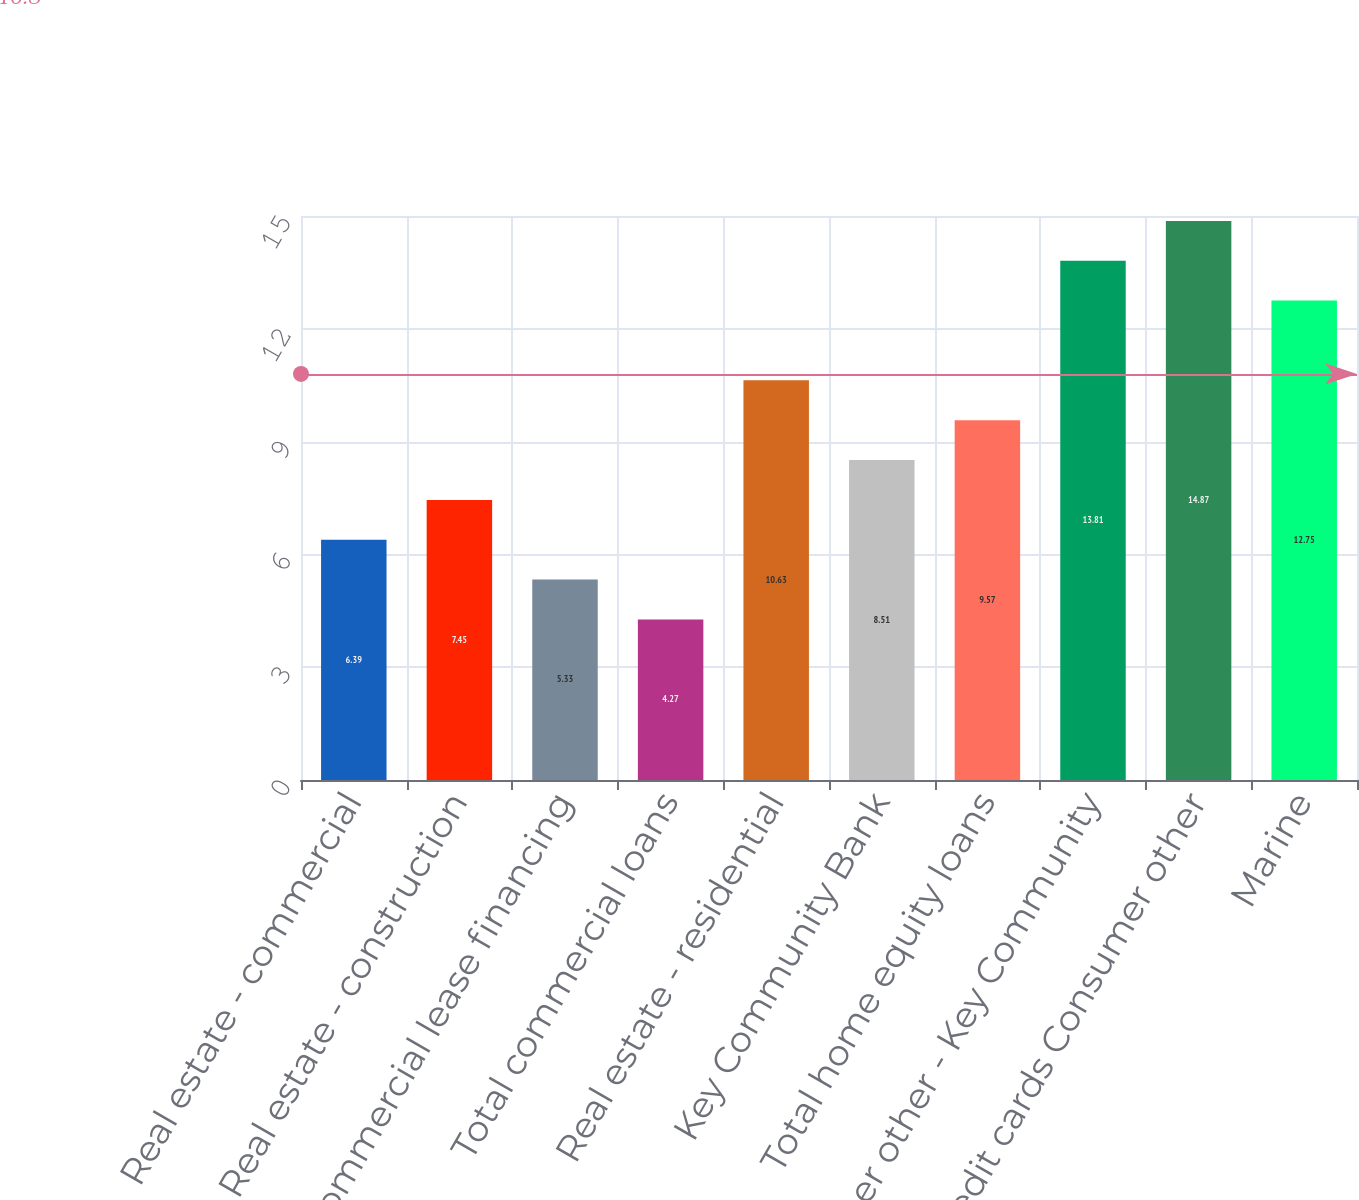<chart> <loc_0><loc_0><loc_500><loc_500><bar_chart><fcel>Real estate - commercial<fcel>Real estate - construction<fcel>Commercial lease financing<fcel>Total commercial loans<fcel>Real estate - residential<fcel>Key Community Bank<fcel>Total home equity loans<fcel>Consumer other - Key Community<fcel>Credit cards Consumer other<fcel>Marine<nl><fcel>6.39<fcel>7.45<fcel>5.33<fcel>4.27<fcel>10.63<fcel>8.51<fcel>9.57<fcel>13.81<fcel>14.87<fcel>12.75<nl></chart> 